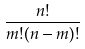<formula> <loc_0><loc_0><loc_500><loc_500>\frac { n ! } { m ! ( n - m ) ! }</formula> 